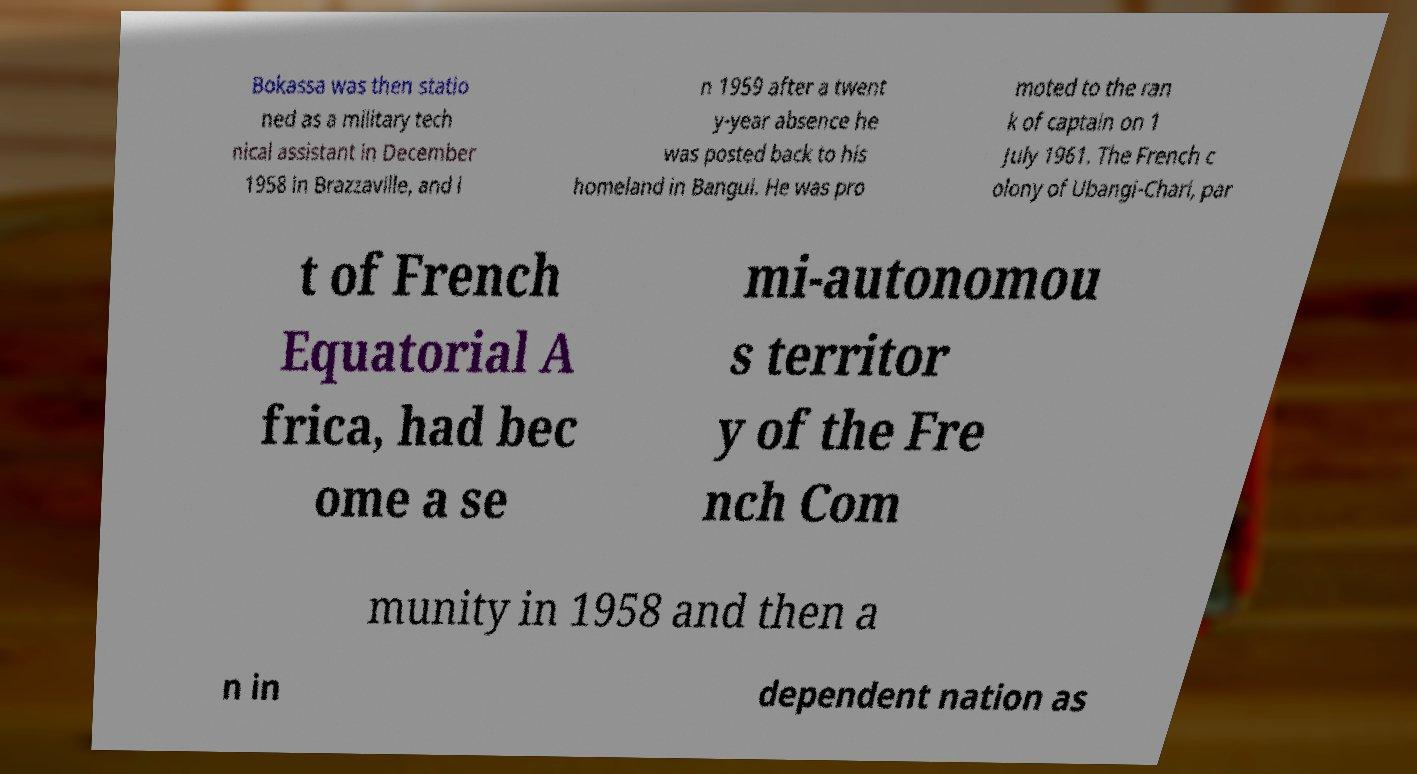Could you extract and type out the text from this image? Bokassa was then statio ned as a military tech nical assistant in December 1958 in Brazzaville, and i n 1959 after a twent y-year absence he was posted back to his homeland in Bangui. He was pro moted to the ran k of captain on 1 July 1961. The French c olony of Ubangi-Chari, par t of French Equatorial A frica, had bec ome a se mi-autonomou s territor y of the Fre nch Com munity in 1958 and then a n in dependent nation as 